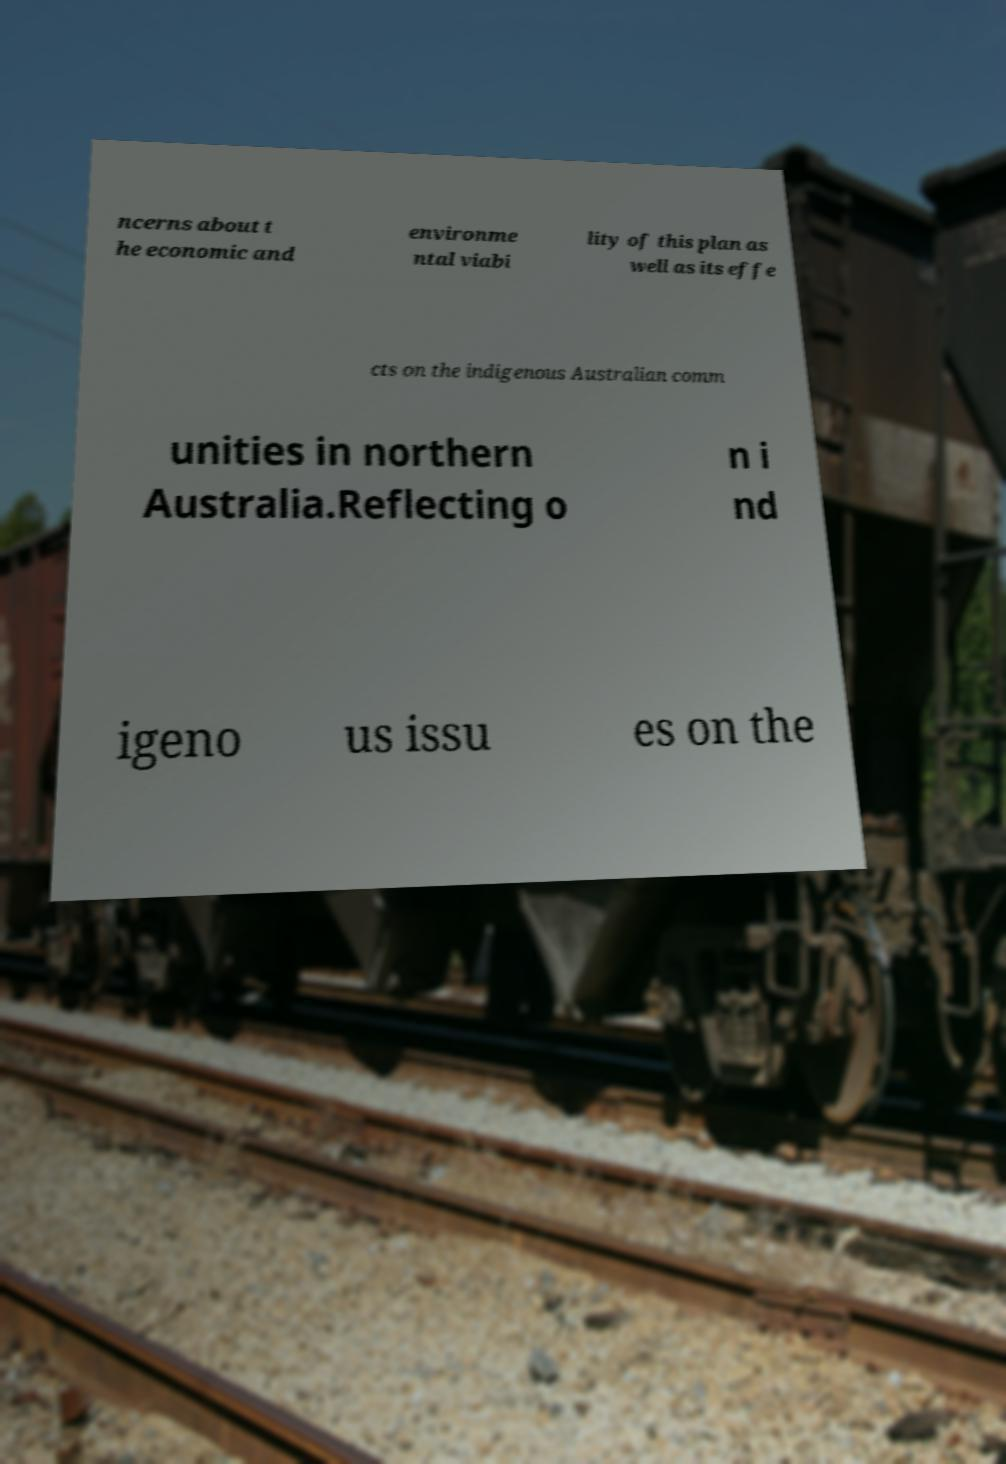Can you accurately transcribe the text from the provided image for me? ncerns about t he economic and environme ntal viabi lity of this plan as well as its effe cts on the indigenous Australian comm unities in northern Australia.Reflecting o n i nd igeno us issu es on the 